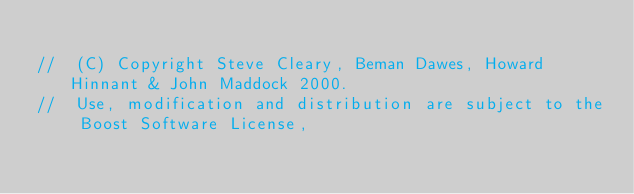<code> <loc_0><loc_0><loc_500><loc_500><_C++_>
//  (C) Copyright Steve Cleary, Beman Dawes, Howard Hinnant & John Maddock 2000.
//  Use, modification and distribution are subject to the Boost Software License,</code> 